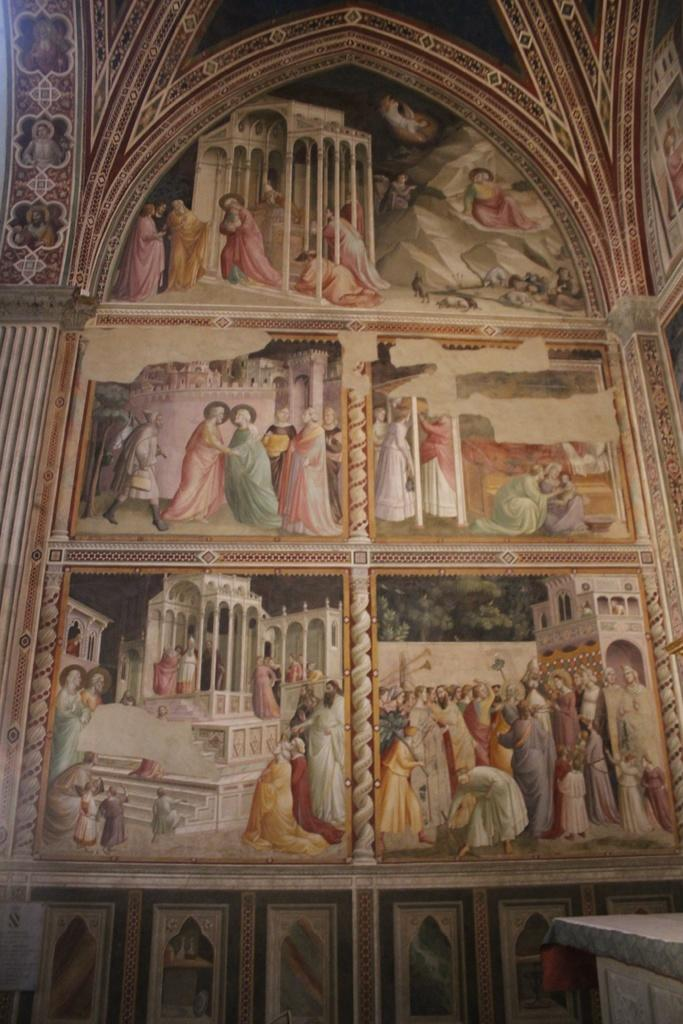What is depicted on the wall in the image? There is a painting of people on the wall. What type of structure can be seen in the image? There is a building in the image. What architectural feature is present in the image? There are pillars in the image. How many daughters are visible in the painting on the wall? There is no mention of daughters in the painting on the wall; it depicts people in general. What type of skin is visible on the ghost in the image? There is no ghost present in the image, so it is not possible to determine the type of skin on a ghost. 